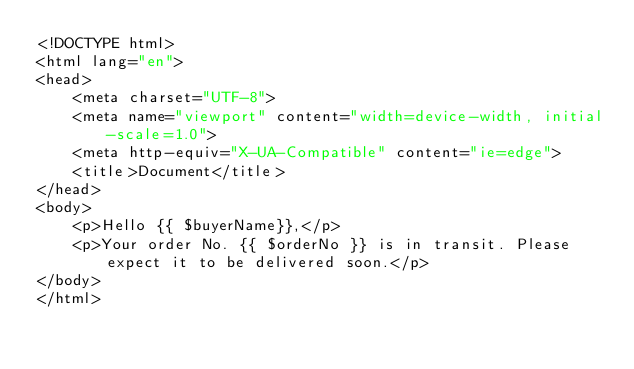<code> <loc_0><loc_0><loc_500><loc_500><_PHP_><!DOCTYPE html>
<html lang="en">
<head>
    <meta charset="UTF-8">
    <meta name="viewport" content="width=device-width, initial-scale=1.0">
    <meta http-equiv="X-UA-Compatible" content="ie=edge">
    <title>Document</title>
</head>
<body>
    <p>Hello {{ $buyerName}},</p>
    <p>Your order No. {{ $orderNo }} is in transit. Please expect it to be delivered soon.</p>
</body>
</html>
</code> 